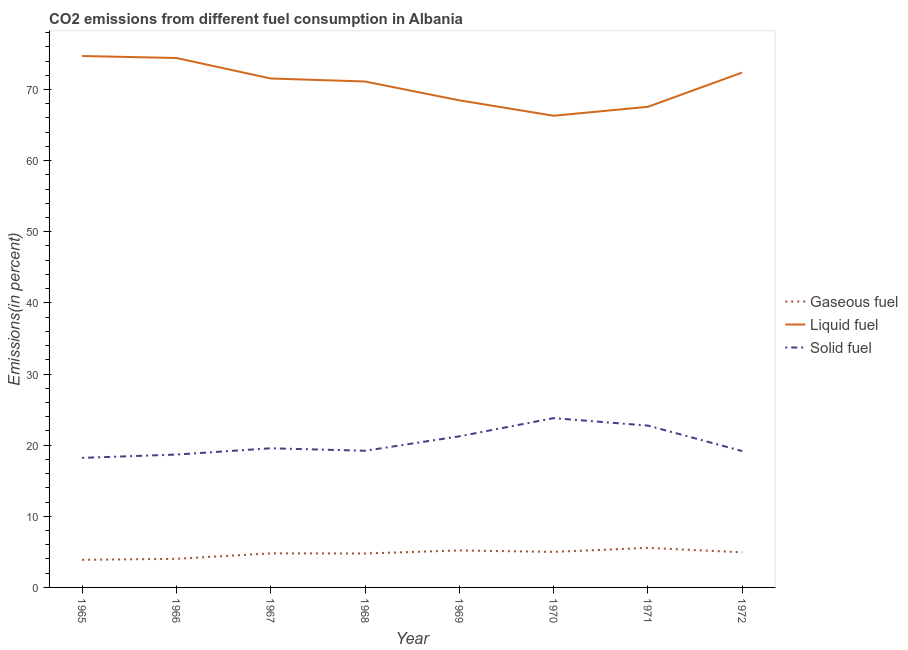Is the number of lines equal to the number of legend labels?
Ensure brevity in your answer.  Yes. What is the percentage of liquid fuel emission in 1971?
Provide a succinct answer. 67.57. Across all years, what is the maximum percentage of liquid fuel emission?
Your answer should be compact. 74.7. Across all years, what is the minimum percentage of liquid fuel emission?
Provide a succinct answer. 66.31. In which year was the percentage of gaseous fuel emission minimum?
Provide a succinct answer. 1965. What is the total percentage of liquid fuel emission in the graph?
Provide a short and direct response. 566.53. What is the difference between the percentage of solid fuel emission in 1968 and that in 1971?
Provide a short and direct response. -3.53. What is the difference between the percentage of liquid fuel emission in 1971 and the percentage of gaseous fuel emission in 1968?
Offer a terse response. 62.79. What is the average percentage of solid fuel emission per year?
Provide a short and direct response. 20.33. In the year 1967, what is the difference between the percentage of gaseous fuel emission and percentage of solid fuel emission?
Ensure brevity in your answer.  -14.77. What is the ratio of the percentage of liquid fuel emission in 1965 to that in 1968?
Keep it short and to the point. 1.05. What is the difference between the highest and the second highest percentage of liquid fuel emission?
Offer a very short reply. 0.28. What is the difference between the highest and the lowest percentage of liquid fuel emission?
Your answer should be compact. 8.4. Is the percentage of liquid fuel emission strictly greater than the percentage of solid fuel emission over the years?
Provide a succinct answer. Yes. How many years are there in the graph?
Ensure brevity in your answer.  8. Does the graph contain grids?
Your response must be concise. No. How are the legend labels stacked?
Your response must be concise. Vertical. What is the title of the graph?
Provide a short and direct response. CO2 emissions from different fuel consumption in Albania. Does "Other sectors" appear as one of the legend labels in the graph?
Give a very brief answer. No. What is the label or title of the Y-axis?
Offer a very short reply. Emissions(in percent). What is the Emissions(in percent) of Gaseous fuel in 1965?
Your answer should be very brief. 3.88. What is the Emissions(in percent) of Liquid fuel in 1965?
Your answer should be very brief. 74.7. What is the Emissions(in percent) in Solid fuel in 1965?
Provide a short and direct response. 18.21. What is the Emissions(in percent) of Gaseous fuel in 1966?
Your answer should be very brief. 4.02. What is the Emissions(in percent) of Liquid fuel in 1966?
Your answer should be compact. 74.43. What is the Emissions(in percent) in Solid fuel in 1966?
Your answer should be compact. 18.68. What is the Emissions(in percent) of Gaseous fuel in 1967?
Your response must be concise. 4.79. What is the Emissions(in percent) in Liquid fuel in 1967?
Keep it short and to the point. 71.55. What is the Emissions(in percent) of Solid fuel in 1967?
Your response must be concise. 19.56. What is the Emissions(in percent) in Gaseous fuel in 1968?
Your answer should be very brief. 4.77. What is the Emissions(in percent) of Liquid fuel in 1968?
Make the answer very short. 71.12. What is the Emissions(in percent) of Solid fuel in 1968?
Your answer should be compact. 19.21. What is the Emissions(in percent) in Gaseous fuel in 1969?
Your answer should be compact. 5.2. What is the Emissions(in percent) of Liquid fuel in 1969?
Your response must be concise. 68.47. What is the Emissions(in percent) in Solid fuel in 1969?
Provide a short and direct response. 21.24. What is the Emissions(in percent) in Gaseous fuel in 1970?
Your answer should be compact. 5. What is the Emissions(in percent) in Liquid fuel in 1970?
Your answer should be compact. 66.31. What is the Emissions(in percent) in Solid fuel in 1970?
Keep it short and to the point. 23.8. What is the Emissions(in percent) of Gaseous fuel in 1971?
Keep it short and to the point. 5.56. What is the Emissions(in percent) in Liquid fuel in 1971?
Offer a terse response. 67.57. What is the Emissions(in percent) of Solid fuel in 1971?
Offer a very short reply. 22.75. What is the Emissions(in percent) in Gaseous fuel in 1972?
Keep it short and to the point. 4.94. What is the Emissions(in percent) in Liquid fuel in 1972?
Your response must be concise. 72.38. What is the Emissions(in percent) of Solid fuel in 1972?
Your answer should be compact. 19.17. Across all years, what is the maximum Emissions(in percent) of Gaseous fuel?
Offer a very short reply. 5.56. Across all years, what is the maximum Emissions(in percent) in Liquid fuel?
Your answer should be very brief. 74.7. Across all years, what is the maximum Emissions(in percent) of Solid fuel?
Provide a short and direct response. 23.8. Across all years, what is the minimum Emissions(in percent) in Gaseous fuel?
Offer a terse response. 3.88. Across all years, what is the minimum Emissions(in percent) of Liquid fuel?
Provide a short and direct response. 66.31. Across all years, what is the minimum Emissions(in percent) in Solid fuel?
Offer a terse response. 18.21. What is the total Emissions(in percent) of Gaseous fuel in the graph?
Offer a very short reply. 38.15. What is the total Emissions(in percent) in Liquid fuel in the graph?
Give a very brief answer. 566.53. What is the total Emissions(in percent) in Solid fuel in the graph?
Your answer should be compact. 162.62. What is the difference between the Emissions(in percent) of Gaseous fuel in 1965 and that in 1966?
Your answer should be compact. -0.14. What is the difference between the Emissions(in percent) in Liquid fuel in 1965 and that in 1966?
Keep it short and to the point. 0.28. What is the difference between the Emissions(in percent) in Solid fuel in 1965 and that in 1966?
Provide a succinct answer. -0.47. What is the difference between the Emissions(in percent) of Gaseous fuel in 1965 and that in 1967?
Offer a very short reply. -0.91. What is the difference between the Emissions(in percent) of Liquid fuel in 1965 and that in 1967?
Provide a short and direct response. 3.16. What is the difference between the Emissions(in percent) in Solid fuel in 1965 and that in 1967?
Make the answer very short. -1.35. What is the difference between the Emissions(in percent) in Gaseous fuel in 1965 and that in 1968?
Provide a succinct answer. -0.89. What is the difference between the Emissions(in percent) of Liquid fuel in 1965 and that in 1968?
Provide a succinct answer. 3.58. What is the difference between the Emissions(in percent) in Solid fuel in 1965 and that in 1968?
Provide a succinct answer. -1. What is the difference between the Emissions(in percent) in Gaseous fuel in 1965 and that in 1969?
Your answer should be compact. -1.32. What is the difference between the Emissions(in percent) in Liquid fuel in 1965 and that in 1969?
Give a very brief answer. 6.23. What is the difference between the Emissions(in percent) in Solid fuel in 1965 and that in 1969?
Provide a succinct answer. -3.03. What is the difference between the Emissions(in percent) of Gaseous fuel in 1965 and that in 1970?
Provide a succinct answer. -1.12. What is the difference between the Emissions(in percent) in Liquid fuel in 1965 and that in 1970?
Your answer should be compact. 8.4. What is the difference between the Emissions(in percent) of Solid fuel in 1965 and that in 1970?
Your response must be concise. -5.59. What is the difference between the Emissions(in percent) in Gaseous fuel in 1965 and that in 1971?
Offer a terse response. -1.68. What is the difference between the Emissions(in percent) in Liquid fuel in 1965 and that in 1971?
Your response must be concise. 7.14. What is the difference between the Emissions(in percent) of Solid fuel in 1965 and that in 1971?
Give a very brief answer. -4.53. What is the difference between the Emissions(in percent) of Gaseous fuel in 1965 and that in 1972?
Your response must be concise. -1.06. What is the difference between the Emissions(in percent) of Liquid fuel in 1965 and that in 1972?
Provide a succinct answer. 2.32. What is the difference between the Emissions(in percent) of Solid fuel in 1965 and that in 1972?
Your answer should be compact. -0.96. What is the difference between the Emissions(in percent) in Gaseous fuel in 1966 and that in 1967?
Your answer should be very brief. -0.77. What is the difference between the Emissions(in percent) of Liquid fuel in 1966 and that in 1967?
Keep it short and to the point. 2.88. What is the difference between the Emissions(in percent) of Solid fuel in 1966 and that in 1967?
Give a very brief answer. -0.88. What is the difference between the Emissions(in percent) in Gaseous fuel in 1966 and that in 1968?
Provide a succinct answer. -0.75. What is the difference between the Emissions(in percent) in Liquid fuel in 1966 and that in 1968?
Your answer should be very brief. 3.3. What is the difference between the Emissions(in percent) of Solid fuel in 1966 and that in 1968?
Keep it short and to the point. -0.53. What is the difference between the Emissions(in percent) of Gaseous fuel in 1966 and that in 1969?
Keep it short and to the point. -1.17. What is the difference between the Emissions(in percent) in Liquid fuel in 1966 and that in 1969?
Make the answer very short. 5.95. What is the difference between the Emissions(in percent) in Solid fuel in 1966 and that in 1969?
Your response must be concise. -2.56. What is the difference between the Emissions(in percent) of Gaseous fuel in 1966 and that in 1970?
Ensure brevity in your answer.  -0.97. What is the difference between the Emissions(in percent) in Liquid fuel in 1966 and that in 1970?
Give a very brief answer. 8.12. What is the difference between the Emissions(in percent) of Solid fuel in 1966 and that in 1970?
Your answer should be very brief. -5.12. What is the difference between the Emissions(in percent) in Gaseous fuel in 1966 and that in 1971?
Keep it short and to the point. -1.54. What is the difference between the Emissions(in percent) of Liquid fuel in 1966 and that in 1971?
Keep it short and to the point. 6.86. What is the difference between the Emissions(in percent) of Solid fuel in 1966 and that in 1971?
Ensure brevity in your answer.  -4.07. What is the difference between the Emissions(in percent) in Gaseous fuel in 1966 and that in 1972?
Offer a terse response. -0.92. What is the difference between the Emissions(in percent) in Liquid fuel in 1966 and that in 1972?
Provide a short and direct response. 2.04. What is the difference between the Emissions(in percent) of Solid fuel in 1966 and that in 1972?
Give a very brief answer. -0.49. What is the difference between the Emissions(in percent) in Gaseous fuel in 1967 and that in 1968?
Provide a short and direct response. 0.01. What is the difference between the Emissions(in percent) in Liquid fuel in 1967 and that in 1968?
Your answer should be very brief. 0.42. What is the difference between the Emissions(in percent) in Solid fuel in 1967 and that in 1968?
Your answer should be very brief. 0.35. What is the difference between the Emissions(in percent) in Gaseous fuel in 1967 and that in 1969?
Ensure brevity in your answer.  -0.41. What is the difference between the Emissions(in percent) of Liquid fuel in 1967 and that in 1969?
Keep it short and to the point. 3.07. What is the difference between the Emissions(in percent) of Solid fuel in 1967 and that in 1969?
Offer a terse response. -1.68. What is the difference between the Emissions(in percent) in Gaseous fuel in 1967 and that in 1970?
Offer a very short reply. -0.21. What is the difference between the Emissions(in percent) of Liquid fuel in 1967 and that in 1970?
Make the answer very short. 5.24. What is the difference between the Emissions(in percent) in Solid fuel in 1967 and that in 1970?
Give a very brief answer. -4.24. What is the difference between the Emissions(in percent) of Gaseous fuel in 1967 and that in 1971?
Provide a short and direct response. -0.77. What is the difference between the Emissions(in percent) of Liquid fuel in 1967 and that in 1971?
Offer a very short reply. 3.98. What is the difference between the Emissions(in percent) of Solid fuel in 1967 and that in 1971?
Make the answer very short. -3.18. What is the difference between the Emissions(in percent) in Gaseous fuel in 1967 and that in 1972?
Make the answer very short. -0.15. What is the difference between the Emissions(in percent) in Liquid fuel in 1967 and that in 1972?
Give a very brief answer. -0.84. What is the difference between the Emissions(in percent) in Solid fuel in 1967 and that in 1972?
Keep it short and to the point. 0.39. What is the difference between the Emissions(in percent) of Gaseous fuel in 1968 and that in 1969?
Offer a terse response. -0.42. What is the difference between the Emissions(in percent) in Liquid fuel in 1968 and that in 1969?
Ensure brevity in your answer.  2.65. What is the difference between the Emissions(in percent) in Solid fuel in 1968 and that in 1969?
Your answer should be compact. -2.03. What is the difference between the Emissions(in percent) of Gaseous fuel in 1968 and that in 1970?
Your response must be concise. -0.22. What is the difference between the Emissions(in percent) of Liquid fuel in 1968 and that in 1970?
Offer a terse response. 4.81. What is the difference between the Emissions(in percent) in Solid fuel in 1968 and that in 1970?
Provide a short and direct response. -4.59. What is the difference between the Emissions(in percent) in Gaseous fuel in 1968 and that in 1971?
Keep it short and to the point. -0.79. What is the difference between the Emissions(in percent) in Liquid fuel in 1968 and that in 1971?
Your response must be concise. 3.56. What is the difference between the Emissions(in percent) in Solid fuel in 1968 and that in 1971?
Offer a very short reply. -3.53. What is the difference between the Emissions(in percent) in Gaseous fuel in 1968 and that in 1972?
Provide a succinct answer. -0.17. What is the difference between the Emissions(in percent) in Liquid fuel in 1968 and that in 1972?
Provide a short and direct response. -1.26. What is the difference between the Emissions(in percent) of Solid fuel in 1968 and that in 1972?
Your answer should be compact. 0.04. What is the difference between the Emissions(in percent) in Gaseous fuel in 1969 and that in 1970?
Your answer should be compact. 0.2. What is the difference between the Emissions(in percent) in Liquid fuel in 1969 and that in 1970?
Keep it short and to the point. 2.17. What is the difference between the Emissions(in percent) of Solid fuel in 1969 and that in 1970?
Your response must be concise. -2.56. What is the difference between the Emissions(in percent) in Gaseous fuel in 1969 and that in 1971?
Offer a very short reply. -0.36. What is the difference between the Emissions(in percent) of Liquid fuel in 1969 and that in 1971?
Provide a succinct answer. 0.91. What is the difference between the Emissions(in percent) of Solid fuel in 1969 and that in 1971?
Make the answer very short. -1.5. What is the difference between the Emissions(in percent) in Gaseous fuel in 1969 and that in 1972?
Make the answer very short. 0.26. What is the difference between the Emissions(in percent) in Liquid fuel in 1969 and that in 1972?
Give a very brief answer. -3.91. What is the difference between the Emissions(in percent) in Solid fuel in 1969 and that in 1972?
Make the answer very short. 2.07. What is the difference between the Emissions(in percent) in Gaseous fuel in 1970 and that in 1971?
Your answer should be compact. -0.57. What is the difference between the Emissions(in percent) of Liquid fuel in 1970 and that in 1971?
Offer a very short reply. -1.26. What is the difference between the Emissions(in percent) of Solid fuel in 1970 and that in 1971?
Keep it short and to the point. 1.05. What is the difference between the Emissions(in percent) of Gaseous fuel in 1970 and that in 1972?
Make the answer very short. 0.06. What is the difference between the Emissions(in percent) in Liquid fuel in 1970 and that in 1972?
Provide a succinct answer. -6.08. What is the difference between the Emissions(in percent) in Solid fuel in 1970 and that in 1972?
Provide a short and direct response. 4.63. What is the difference between the Emissions(in percent) in Gaseous fuel in 1971 and that in 1972?
Provide a succinct answer. 0.62. What is the difference between the Emissions(in percent) of Liquid fuel in 1971 and that in 1972?
Make the answer very short. -4.82. What is the difference between the Emissions(in percent) of Solid fuel in 1971 and that in 1972?
Give a very brief answer. 3.58. What is the difference between the Emissions(in percent) of Gaseous fuel in 1965 and the Emissions(in percent) of Liquid fuel in 1966?
Your answer should be very brief. -70.55. What is the difference between the Emissions(in percent) in Gaseous fuel in 1965 and the Emissions(in percent) in Solid fuel in 1966?
Offer a very short reply. -14.8. What is the difference between the Emissions(in percent) of Liquid fuel in 1965 and the Emissions(in percent) of Solid fuel in 1966?
Offer a very short reply. 56.03. What is the difference between the Emissions(in percent) of Gaseous fuel in 1965 and the Emissions(in percent) of Liquid fuel in 1967?
Provide a succinct answer. -67.67. What is the difference between the Emissions(in percent) of Gaseous fuel in 1965 and the Emissions(in percent) of Solid fuel in 1967?
Offer a terse response. -15.68. What is the difference between the Emissions(in percent) in Liquid fuel in 1965 and the Emissions(in percent) in Solid fuel in 1967?
Your response must be concise. 55.14. What is the difference between the Emissions(in percent) of Gaseous fuel in 1965 and the Emissions(in percent) of Liquid fuel in 1968?
Ensure brevity in your answer.  -67.24. What is the difference between the Emissions(in percent) of Gaseous fuel in 1965 and the Emissions(in percent) of Solid fuel in 1968?
Offer a terse response. -15.33. What is the difference between the Emissions(in percent) in Liquid fuel in 1965 and the Emissions(in percent) in Solid fuel in 1968?
Your response must be concise. 55.49. What is the difference between the Emissions(in percent) in Gaseous fuel in 1965 and the Emissions(in percent) in Liquid fuel in 1969?
Ensure brevity in your answer.  -64.6. What is the difference between the Emissions(in percent) in Gaseous fuel in 1965 and the Emissions(in percent) in Solid fuel in 1969?
Your response must be concise. -17.36. What is the difference between the Emissions(in percent) of Liquid fuel in 1965 and the Emissions(in percent) of Solid fuel in 1969?
Provide a succinct answer. 53.46. What is the difference between the Emissions(in percent) of Gaseous fuel in 1965 and the Emissions(in percent) of Liquid fuel in 1970?
Offer a very short reply. -62.43. What is the difference between the Emissions(in percent) of Gaseous fuel in 1965 and the Emissions(in percent) of Solid fuel in 1970?
Give a very brief answer. -19.92. What is the difference between the Emissions(in percent) of Liquid fuel in 1965 and the Emissions(in percent) of Solid fuel in 1970?
Offer a terse response. 50.9. What is the difference between the Emissions(in percent) in Gaseous fuel in 1965 and the Emissions(in percent) in Liquid fuel in 1971?
Provide a short and direct response. -63.69. What is the difference between the Emissions(in percent) of Gaseous fuel in 1965 and the Emissions(in percent) of Solid fuel in 1971?
Offer a terse response. -18.87. What is the difference between the Emissions(in percent) of Liquid fuel in 1965 and the Emissions(in percent) of Solid fuel in 1971?
Your answer should be compact. 51.96. What is the difference between the Emissions(in percent) of Gaseous fuel in 1965 and the Emissions(in percent) of Liquid fuel in 1972?
Make the answer very short. -68.51. What is the difference between the Emissions(in percent) in Gaseous fuel in 1965 and the Emissions(in percent) in Solid fuel in 1972?
Provide a succinct answer. -15.29. What is the difference between the Emissions(in percent) in Liquid fuel in 1965 and the Emissions(in percent) in Solid fuel in 1972?
Your response must be concise. 55.54. What is the difference between the Emissions(in percent) of Gaseous fuel in 1966 and the Emissions(in percent) of Liquid fuel in 1967?
Make the answer very short. -67.52. What is the difference between the Emissions(in percent) of Gaseous fuel in 1966 and the Emissions(in percent) of Solid fuel in 1967?
Provide a short and direct response. -15.54. What is the difference between the Emissions(in percent) of Liquid fuel in 1966 and the Emissions(in percent) of Solid fuel in 1967?
Provide a succinct answer. 54.86. What is the difference between the Emissions(in percent) of Gaseous fuel in 1966 and the Emissions(in percent) of Liquid fuel in 1968?
Make the answer very short. -67.1. What is the difference between the Emissions(in percent) in Gaseous fuel in 1966 and the Emissions(in percent) in Solid fuel in 1968?
Provide a succinct answer. -15.19. What is the difference between the Emissions(in percent) of Liquid fuel in 1966 and the Emissions(in percent) of Solid fuel in 1968?
Provide a succinct answer. 55.21. What is the difference between the Emissions(in percent) of Gaseous fuel in 1966 and the Emissions(in percent) of Liquid fuel in 1969?
Your response must be concise. -64.45. What is the difference between the Emissions(in percent) in Gaseous fuel in 1966 and the Emissions(in percent) in Solid fuel in 1969?
Offer a very short reply. -17.22. What is the difference between the Emissions(in percent) of Liquid fuel in 1966 and the Emissions(in percent) of Solid fuel in 1969?
Offer a terse response. 53.18. What is the difference between the Emissions(in percent) of Gaseous fuel in 1966 and the Emissions(in percent) of Liquid fuel in 1970?
Your answer should be compact. -62.28. What is the difference between the Emissions(in percent) in Gaseous fuel in 1966 and the Emissions(in percent) in Solid fuel in 1970?
Provide a short and direct response. -19.78. What is the difference between the Emissions(in percent) in Liquid fuel in 1966 and the Emissions(in percent) in Solid fuel in 1970?
Make the answer very short. 50.63. What is the difference between the Emissions(in percent) in Gaseous fuel in 1966 and the Emissions(in percent) in Liquid fuel in 1971?
Your answer should be very brief. -63.54. What is the difference between the Emissions(in percent) of Gaseous fuel in 1966 and the Emissions(in percent) of Solid fuel in 1971?
Make the answer very short. -18.72. What is the difference between the Emissions(in percent) in Liquid fuel in 1966 and the Emissions(in percent) in Solid fuel in 1971?
Offer a terse response. 51.68. What is the difference between the Emissions(in percent) of Gaseous fuel in 1966 and the Emissions(in percent) of Liquid fuel in 1972?
Keep it short and to the point. -68.36. What is the difference between the Emissions(in percent) in Gaseous fuel in 1966 and the Emissions(in percent) in Solid fuel in 1972?
Make the answer very short. -15.15. What is the difference between the Emissions(in percent) in Liquid fuel in 1966 and the Emissions(in percent) in Solid fuel in 1972?
Keep it short and to the point. 55.26. What is the difference between the Emissions(in percent) in Gaseous fuel in 1967 and the Emissions(in percent) in Liquid fuel in 1968?
Your answer should be compact. -66.33. What is the difference between the Emissions(in percent) in Gaseous fuel in 1967 and the Emissions(in percent) in Solid fuel in 1968?
Offer a terse response. -14.42. What is the difference between the Emissions(in percent) of Liquid fuel in 1967 and the Emissions(in percent) of Solid fuel in 1968?
Make the answer very short. 52.33. What is the difference between the Emissions(in percent) of Gaseous fuel in 1967 and the Emissions(in percent) of Liquid fuel in 1969?
Make the answer very short. -63.69. What is the difference between the Emissions(in percent) in Gaseous fuel in 1967 and the Emissions(in percent) in Solid fuel in 1969?
Make the answer very short. -16.45. What is the difference between the Emissions(in percent) of Liquid fuel in 1967 and the Emissions(in percent) of Solid fuel in 1969?
Your answer should be compact. 50.3. What is the difference between the Emissions(in percent) in Gaseous fuel in 1967 and the Emissions(in percent) in Liquid fuel in 1970?
Give a very brief answer. -61.52. What is the difference between the Emissions(in percent) of Gaseous fuel in 1967 and the Emissions(in percent) of Solid fuel in 1970?
Your response must be concise. -19.01. What is the difference between the Emissions(in percent) in Liquid fuel in 1967 and the Emissions(in percent) in Solid fuel in 1970?
Give a very brief answer. 47.75. What is the difference between the Emissions(in percent) of Gaseous fuel in 1967 and the Emissions(in percent) of Liquid fuel in 1971?
Offer a very short reply. -62.78. What is the difference between the Emissions(in percent) in Gaseous fuel in 1967 and the Emissions(in percent) in Solid fuel in 1971?
Your answer should be compact. -17.96. What is the difference between the Emissions(in percent) in Liquid fuel in 1967 and the Emissions(in percent) in Solid fuel in 1971?
Your answer should be compact. 48.8. What is the difference between the Emissions(in percent) in Gaseous fuel in 1967 and the Emissions(in percent) in Liquid fuel in 1972?
Keep it short and to the point. -67.6. What is the difference between the Emissions(in percent) of Gaseous fuel in 1967 and the Emissions(in percent) of Solid fuel in 1972?
Keep it short and to the point. -14.38. What is the difference between the Emissions(in percent) in Liquid fuel in 1967 and the Emissions(in percent) in Solid fuel in 1972?
Your answer should be very brief. 52.38. What is the difference between the Emissions(in percent) of Gaseous fuel in 1968 and the Emissions(in percent) of Liquid fuel in 1969?
Keep it short and to the point. -63.7. What is the difference between the Emissions(in percent) of Gaseous fuel in 1968 and the Emissions(in percent) of Solid fuel in 1969?
Your response must be concise. -16.47. What is the difference between the Emissions(in percent) in Liquid fuel in 1968 and the Emissions(in percent) in Solid fuel in 1969?
Make the answer very short. 49.88. What is the difference between the Emissions(in percent) in Gaseous fuel in 1968 and the Emissions(in percent) in Liquid fuel in 1970?
Ensure brevity in your answer.  -61.53. What is the difference between the Emissions(in percent) of Gaseous fuel in 1968 and the Emissions(in percent) of Solid fuel in 1970?
Ensure brevity in your answer.  -19.03. What is the difference between the Emissions(in percent) in Liquid fuel in 1968 and the Emissions(in percent) in Solid fuel in 1970?
Provide a short and direct response. 47.32. What is the difference between the Emissions(in percent) of Gaseous fuel in 1968 and the Emissions(in percent) of Liquid fuel in 1971?
Your answer should be very brief. -62.79. What is the difference between the Emissions(in percent) in Gaseous fuel in 1968 and the Emissions(in percent) in Solid fuel in 1971?
Your answer should be compact. -17.97. What is the difference between the Emissions(in percent) in Liquid fuel in 1968 and the Emissions(in percent) in Solid fuel in 1971?
Ensure brevity in your answer.  48.38. What is the difference between the Emissions(in percent) in Gaseous fuel in 1968 and the Emissions(in percent) in Liquid fuel in 1972?
Keep it short and to the point. -67.61. What is the difference between the Emissions(in percent) of Gaseous fuel in 1968 and the Emissions(in percent) of Solid fuel in 1972?
Make the answer very short. -14.39. What is the difference between the Emissions(in percent) in Liquid fuel in 1968 and the Emissions(in percent) in Solid fuel in 1972?
Provide a short and direct response. 51.95. What is the difference between the Emissions(in percent) of Gaseous fuel in 1969 and the Emissions(in percent) of Liquid fuel in 1970?
Provide a short and direct response. -61.11. What is the difference between the Emissions(in percent) in Gaseous fuel in 1969 and the Emissions(in percent) in Solid fuel in 1970?
Offer a terse response. -18.6. What is the difference between the Emissions(in percent) in Liquid fuel in 1969 and the Emissions(in percent) in Solid fuel in 1970?
Your answer should be compact. 44.67. What is the difference between the Emissions(in percent) in Gaseous fuel in 1969 and the Emissions(in percent) in Liquid fuel in 1971?
Your answer should be very brief. -62.37. What is the difference between the Emissions(in percent) in Gaseous fuel in 1969 and the Emissions(in percent) in Solid fuel in 1971?
Offer a very short reply. -17.55. What is the difference between the Emissions(in percent) of Liquid fuel in 1969 and the Emissions(in percent) of Solid fuel in 1971?
Offer a terse response. 45.73. What is the difference between the Emissions(in percent) in Gaseous fuel in 1969 and the Emissions(in percent) in Liquid fuel in 1972?
Your answer should be very brief. -67.19. What is the difference between the Emissions(in percent) of Gaseous fuel in 1969 and the Emissions(in percent) of Solid fuel in 1972?
Offer a very short reply. -13.97. What is the difference between the Emissions(in percent) in Liquid fuel in 1969 and the Emissions(in percent) in Solid fuel in 1972?
Keep it short and to the point. 49.31. What is the difference between the Emissions(in percent) of Gaseous fuel in 1970 and the Emissions(in percent) of Liquid fuel in 1971?
Your answer should be compact. -62.57. What is the difference between the Emissions(in percent) in Gaseous fuel in 1970 and the Emissions(in percent) in Solid fuel in 1971?
Your answer should be compact. -17.75. What is the difference between the Emissions(in percent) in Liquid fuel in 1970 and the Emissions(in percent) in Solid fuel in 1971?
Provide a succinct answer. 43.56. What is the difference between the Emissions(in percent) in Gaseous fuel in 1970 and the Emissions(in percent) in Liquid fuel in 1972?
Offer a terse response. -67.39. What is the difference between the Emissions(in percent) of Gaseous fuel in 1970 and the Emissions(in percent) of Solid fuel in 1972?
Give a very brief answer. -14.17. What is the difference between the Emissions(in percent) of Liquid fuel in 1970 and the Emissions(in percent) of Solid fuel in 1972?
Offer a very short reply. 47.14. What is the difference between the Emissions(in percent) in Gaseous fuel in 1971 and the Emissions(in percent) in Liquid fuel in 1972?
Provide a succinct answer. -66.82. What is the difference between the Emissions(in percent) of Gaseous fuel in 1971 and the Emissions(in percent) of Solid fuel in 1972?
Provide a succinct answer. -13.61. What is the difference between the Emissions(in percent) in Liquid fuel in 1971 and the Emissions(in percent) in Solid fuel in 1972?
Your response must be concise. 48.4. What is the average Emissions(in percent) of Gaseous fuel per year?
Your answer should be compact. 4.77. What is the average Emissions(in percent) of Liquid fuel per year?
Make the answer very short. 70.82. What is the average Emissions(in percent) in Solid fuel per year?
Provide a short and direct response. 20.33. In the year 1965, what is the difference between the Emissions(in percent) in Gaseous fuel and Emissions(in percent) in Liquid fuel?
Give a very brief answer. -70.83. In the year 1965, what is the difference between the Emissions(in percent) of Gaseous fuel and Emissions(in percent) of Solid fuel?
Give a very brief answer. -14.33. In the year 1965, what is the difference between the Emissions(in percent) in Liquid fuel and Emissions(in percent) in Solid fuel?
Your answer should be compact. 56.49. In the year 1966, what is the difference between the Emissions(in percent) of Gaseous fuel and Emissions(in percent) of Liquid fuel?
Ensure brevity in your answer.  -70.4. In the year 1966, what is the difference between the Emissions(in percent) of Gaseous fuel and Emissions(in percent) of Solid fuel?
Provide a succinct answer. -14.66. In the year 1966, what is the difference between the Emissions(in percent) of Liquid fuel and Emissions(in percent) of Solid fuel?
Keep it short and to the point. 55.75. In the year 1967, what is the difference between the Emissions(in percent) of Gaseous fuel and Emissions(in percent) of Liquid fuel?
Your answer should be compact. -66.76. In the year 1967, what is the difference between the Emissions(in percent) of Gaseous fuel and Emissions(in percent) of Solid fuel?
Provide a short and direct response. -14.77. In the year 1967, what is the difference between the Emissions(in percent) of Liquid fuel and Emissions(in percent) of Solid fuel?
Provide a short and direct response. 51.98. In the year 1968, what is the difference between the Emissions(in percent) in Gaseous fuel and Emissions(in percent) in Liquid fuel?
Give a very brief answer. -66.35. In the year 1968, what is the difference between the Emissions(in percent) in Gaseous fuel and Emissions(in percent) in Solid fuel?
Offer a very short reply. -14.44. In the year 1968, what is the difference between the Emissions(in percent) of Liquid fuel and Emissions(in percent) of Solid fuel?
Provide a succinct answer. 51.91. In the year 1969, what is the difference between the Emissions(in percent) of Gaseous fuel and Emissions(in percent) of Liquid fuel?
Keep it short and to the point. -63.28. In the year 1969, what is the difference between the Emissions(in percent) of Gaseous fuel and Emissions(in percent) of Solid fuel?
Offer a very short reply. -16.05. In the year 1969, what is the difference between the Emissions(in percent) in Liquid fuel and Emissions(in percent) in Solid fuel?
Your answer should be very brief. 47.23. In the year 1970, what is the difference between the Emissions(in percent) in Gaseous fuel and Emissions(in percent) in Liquid fuel?
Give a very brief answer. -61.31. In the year 1970, what is the difference between the Emissions(in percent) of Gaseous fuel and Emissions(in percent) of Solid fuel?
Provide a short and direct response. -18.81. In the year 1970, what is the difference between the Emissions(in percent) of Liquid fuel and Emissions(in percent) of Solid fuel?
Your answer should be compact. 42.51. In the year 1971, what is the difference between the Emissions(in percent) in Gaseous fuel and Emissions(in percent) in Liquid fuel?
Provide a short and direct response. -62.01. In the year 1971, what is the difference between the Emissions(in percent) of Gaseous fuel and Emissions(in percent) of Solid fuel?
Your answer should be compact. -17.19. In the year 1971, what is the difference between the Emissions(in percent) in Liquid fuel and Emissions(in percent) in Solid fuel?
Offer a very short reply. 44.82. In the year 1972, what is the difference between the Emissions(in percent) in Gaseous fuel and Emissions(in percent) in Liquid fuel?
Provide a short and direct response. -67.45. In the year 1972, what is the difference between the Emissions(in percent) of Gaseous fuel and Emissions(in percent) of Solid fuel?
Your answer should be compact. -14.23. In the year 1972, what is the difference between the Emissions(in percent) of Liquid fuel and Emissions(in percent) of Solid fuel?
Your answer should be compact. 53.22. What is the ratio of the Emissions(in percent) of Gaseous fuel in 1965 to that in 1966?
Ensure brevity in your answer.  0.96. What is the ratio of the Emissions(in percent) of Liquid fuel in 1965 to that in 1966?
Make the answer very short. 1. What is the ratio of the Emissions(in percent) in Solid fuel in 1965 to that in 1966?
Provide a succinct answer. 0.98. What is the ratio of the Emissions(in percent) of Gaseous fuel in 1965 to that in 1967?
Provide a succinct answer. 0.81. What is the ratio of the Emissions(in percent) in Liquid fuel in 1965 to that in 1967?
Make the answer very short. 1.04. What is the ratio of the Emissions(in percent) in Gaseous fuel in 1965 to that in 1968?
Ensure brevity in your answer.  0.81. What is the ratio of the Emissions(in percent) in Liquid fuel in 1965 to that in 1968?
Give a very brief answer. 1.05. What is the ratio of the Emissions(in percent) in Solid fuel in 1965 to that in 1968?
Offer a very short reply. 0.95. What is the ratio of the Emissions(in percent) in Gaseous fuel in 1965 to that in 1969?
Your answer should be compact. 0.75. What is the ratio of the Emissions(in percent) of Liquid fuel in 1965 to that in 1969?
Give a very brief answer. 1.09. What is the ratio of the Emissions(in percent) of Solid fuel in 1965 to that in 1969?
Offer a very short reply. 0.86. What is the ratio of the Emissions(in percent) of Gaseous fuel in 1965 to that in 1970?
Offer a terse response. 0.78. What is the ratio of the Emissions(in percent) in Liquid fuel in 1965 to that in 1970?
Your answer should be very brief. 1.13. What is the ratio of the Emissions(in percent) of Solid fuel in 1965 to that in 1970?
Ensure brevity in your answer.  0.77. What is the ratio of the Emissions(in percent) of Gaseous fuel in 1965 to that in 1971?
Keep it short and to the point. 0.7. What is the ratio of the Emissions(in percent) in Liquid fuel in 1965 to that in 1971?
Provide a short and direct response. 1.11. What is the ratio of the Emissions(in percent) in Solid fuel in 1965 to that in 1971?
Your answer should be compact. 0.8. What is the ratio of the Emissions(in percent) in Gaseous fuel in 1965 to that in 1972?
Your answer should be very brief. 0.79. What is the ratio of the Emissions(in percent) in Liquid fuel in 1965 to that in 1972?
Make the answer very short. 1.03. What is the ratio of the Emissions(in percent) in Solid fuel in 1965 to that in 1972?
Offer a very short reply. 0.95. What is the ratio of the Emissions(in percent) in Gaseous fuel in 1966 to that in 1967?
Provide a short and direct response. 0.84. What is the ratio of the Emissions(in percent) in Liquid fuel in 1966 to that in 1967?
Give a very brief answer. 1.04. What is the ratio of the Emissions(in percent) in Solid fuel in 1966 to that in 1967?
Your answer should be compact. 0.95. What is the ratio of the Emissions(in percent) of Gaseous fuel in 1966 to that in 1968?
Offer a very short reply. 0.84. What is the ratio of the Emissions(in percent) of Liquid fuel in 1966 to that in 1968?
Give a very brief answer. 1.05. What is the ratio of the Emissions(in percent) in Solid fuel in 1966 to that in 1968?
Your response must be concise. 0.97. What is the ratio of the Emissions(in percent) in Gaseous fuel in 1966 to that in 1969?
Keep it short and to the point. 0.77. What is the ratio of the Emissions(in percent) in Liquid fuel in 1966 to that in 1969?
Ensure brevity in your answer.  1.09. What is the ratio of the Emissions(in percent) of Solid fuel in 1966 to that in 1969?
Provide a succinct answer. 0.88. What is the ratio of the Emissions(in percent) of Gaseous fuel in 1966 to that in 1970?
Offer a terse response. 0.81. What is the ratio of the Emissions(in percent) in Liquid fuel in 1966 to that in 1970?
Give a very brief answer. 1.12. What is the ratio of the Emissions(in percent) of Solid fuel in 1966 to that in 1970?
Ensure brevity in your answer.  0.78. What is the ratio of the Emissions(in percent) of Gaseous fuel in 1966 to that in 1971?
Ensure brevity in your answer.  0.72. What is the ratio of the Emissions(in percent) of Liquid fuel in 1966 to that in 1971?
Provide a succinct answer. 1.1. What is the ratio of the Emissions(in percent) of Solid fuel in 1966 to that in 1971?
Your response must be concise. 0.82. What is the ratio of the Emissions(in percent) in Gaseous fuel in 1966 to that in 1972?
Your response must be concise. 0.81. What is the ratio of the Emissions(in percent) in Liquid fuel in 1966 to that in 1972?
Your response must be concise. 1.03. What is the ratio of the Emissions(in percent) in Solid fuel in 1966 to that in 1972?
Give a very brief answer. 0.97. What is the ratio of the Emissions(in percent) of Solid fuel in 1967 to that in 1968?
Keep it short and to the point. 1.02. What is the ratio of the Emissions(in percent) in Gaseous fuel in 1967 to that in 1969?
Keep it short and to the point. 0.92. What is the ratio of the Emissions(in percent) of Liquid fuel in 1967 to that in 1969?
Your answer should be compact. 1.04. What is the ratio of the Emissions(in percent) of Solid fuel in 1967 to that in 1969?
Give a very brief answer. 0.92. What is the ratio of the Emissions(in percent) in Gaseous fuel in 1967 to that in 1970?
Offer a terse response. 0.96. What is the ratio of the Emissions(in percent) of Liquid fuel in 1967 to that in 1970?
Provide a succinct answer. 1.08. What is the ratio of the Emissions(in percent) in Solid fuel in 1967 to that in 1970?
Provide a succinct answer. 0.82. What is the ratio of the Emissions(in percent) in Gaseous fuel in 1967 to that in 1971?
Provide a short and direct response. 0.86. What is the ratio of the Emissions(in percent) in Liquid fuel in 1967 to that in 1971?
Your answer should be very brief. 1.06. What is the ratio of the Emissions(in percent) of Solid fuel in 1967 to that in 1971?
Ensure brevity in your answer.  0.86. What is the ratio of the Emissions(in percent) of Gaseous fuel in 1967 to that in 1972?
Provide a short and direct response. 0.97. What is the ratio of the Emissions(in percent) of Liquid fuel in 1967 to that in 1972?
Provide a succinct answer. 0.99. What is the ratio of the Emissions(in percent) in Solid fuel in 1967 to that in 1972?
Provide a short and direct response. 1.02. What is the ratio of the Emissions(in percent) in Gaseous fuel in 1968 to that in 1969?
Give a very brief answer. 0.92. What is the ratio of the Emissions(in percent) of Liquid fuel in 1968 to that in 1969?
Offer a terse response. 1.04. What is the ratio of the Emissions(in percent) in Solid fuel in 1968 to that in 1969?
Provide a succinct answer. 0.9. What is the ratio of the Emissions(in percent) of Gaseous fuel in 1968 to that in 1970?
Your answer should be compact. 0.96. What is the ratio of the Emissions(in percent) of Liquid fuel in 1968 to that in 1970?
Offer a very short reply. 1.07. What is the ratio of the Emissions(in percent) of Solid fuel in 1968 to that in 1970?
Your answer should be compact. 0.81. What is the ratio of the Emissions(in percent) in Gaseous fuel in 1968 to that in 1971?
Your answer should be very brief. 0.86. What is the ratio of the Emissions(in percent) of Liquid fuel in 1968 to that in 1971?
Give a very brief answer. 1.05. What is the ratio of the Emissions(in percent) of Solid fuel in 1968 to that in 1971?
Ensure brevity in your answer.  0.84. What is the ratio of the Emissions(in percent) of Gaseous fuel in 1968 to that in 1972?
Keep it short and to the point. 0.97. What is the ratio of the Emissions(in percent) of Liquid fuel in 1968 to that in 1972?
Your answer should be compact. 0.98. What is the ratio of the Emissions(in percent) of Gaseous fuel in 1969 to that in 1970?
Your answer should be very brief. 1.04. What is the ratio of the Emissions(in percent) of Liquid fuel in 1969 to that in 1970?
Provide a succinct answer. 1.03. What is the ratio of the Emissions(in percent) in Solid fuel in 1969 to that in 1970?
Your response must be concise. 0.89. What is the ratio of the Emissions(in percent) of Gaseous fuel in 1969 to that in 1971?
Make the answer very short. 0.93. What is the ratio of the Emissions(in percent) of Liquid fuel in 1969 to that in 1971?
Provide a short and direct response. 1.01. What is the ratio of the Emissions(in percent) in Solid fuel in 1969 to that in 1971?
Keep it short and to the point. 0.93. What is the ratio of the Emissions(in percent) of Gaseous fuel in 1969 to that in 1972?
Your answer should be compact. 1.05. What is the ratio of the Emissions(in percent) in Liquid fuel in 1969 to that in 1972?
Provide a succinct answer. 0.95. What is the ratio of the Emissions(in percent) of Solid fuel in 1969 to that in 1972?
Your answer should be compact. 1.11. What is the ratio of the Emissions(in percent) of Gaseous fuel in 1970 to that in 1971?
Offer a terse response. 0.9. What is the ratio of the Emissions(in percent) in Liquid fuel in 1970 to that in 1971?
Offer a terse response. 0.98. What is the ratio of the Emissions(in percent) in Solid fuel in 1970 to that in 1971?
Your answer should be very brief. 1.05. What is the ratio of the Emissions(in percent) of Gaseous fuel in 1970 to that in 1972?
Ensure brevity in your answer.  1.01. What is the ratio of the Emissions(in percent) in Liquid fuel in 1970 to that in 1972?
Your response must be concise. 0.92. What is the ratio of the Emissions(in percent) in Solid fuel in 1970 to that in 1972?
Give a very brief answer. 1.24. What is the ratio of the Emissions(in percent) of Gaseous fuel in 1971 to that in 1972?
Provide a succinct answer. 1.13. What is the ratio of the Emissions(in percent) of Liquid fuel in 1971 to that in 1972?
Your answer should be compact. 0.93. What is the ratio of the Emissions(in percent) in Solid fuel in 1971 to that in 1972?
Make the answer very short. 1.19. What is the difference between the highest and the second highest Emissions(in percent) of Gaseous fuel?
Ensure brevity in your answer.  0.36. What is the difference between the highest and the second highest Emissions(in percent) of Liquid fuel?
Your answer should be compact. 0.28. What is the difference between the highest and the second highest Emissions(in percent) in Solid fuel?
Offer a terse response. 1.05. What is the difference between the highest and the lowest Emissions(in percent) in Gaseous fuel?
Offer a very short reply. 1.68. What is the difference between the highest and the lowest Emissions(in percent) in Liquid fuel?
Your answer should be compact. 8.4. What is the difference between the highest and the lowest Emissions(in percent) of Solid fuel?
Your response must be concise. 5.59. 